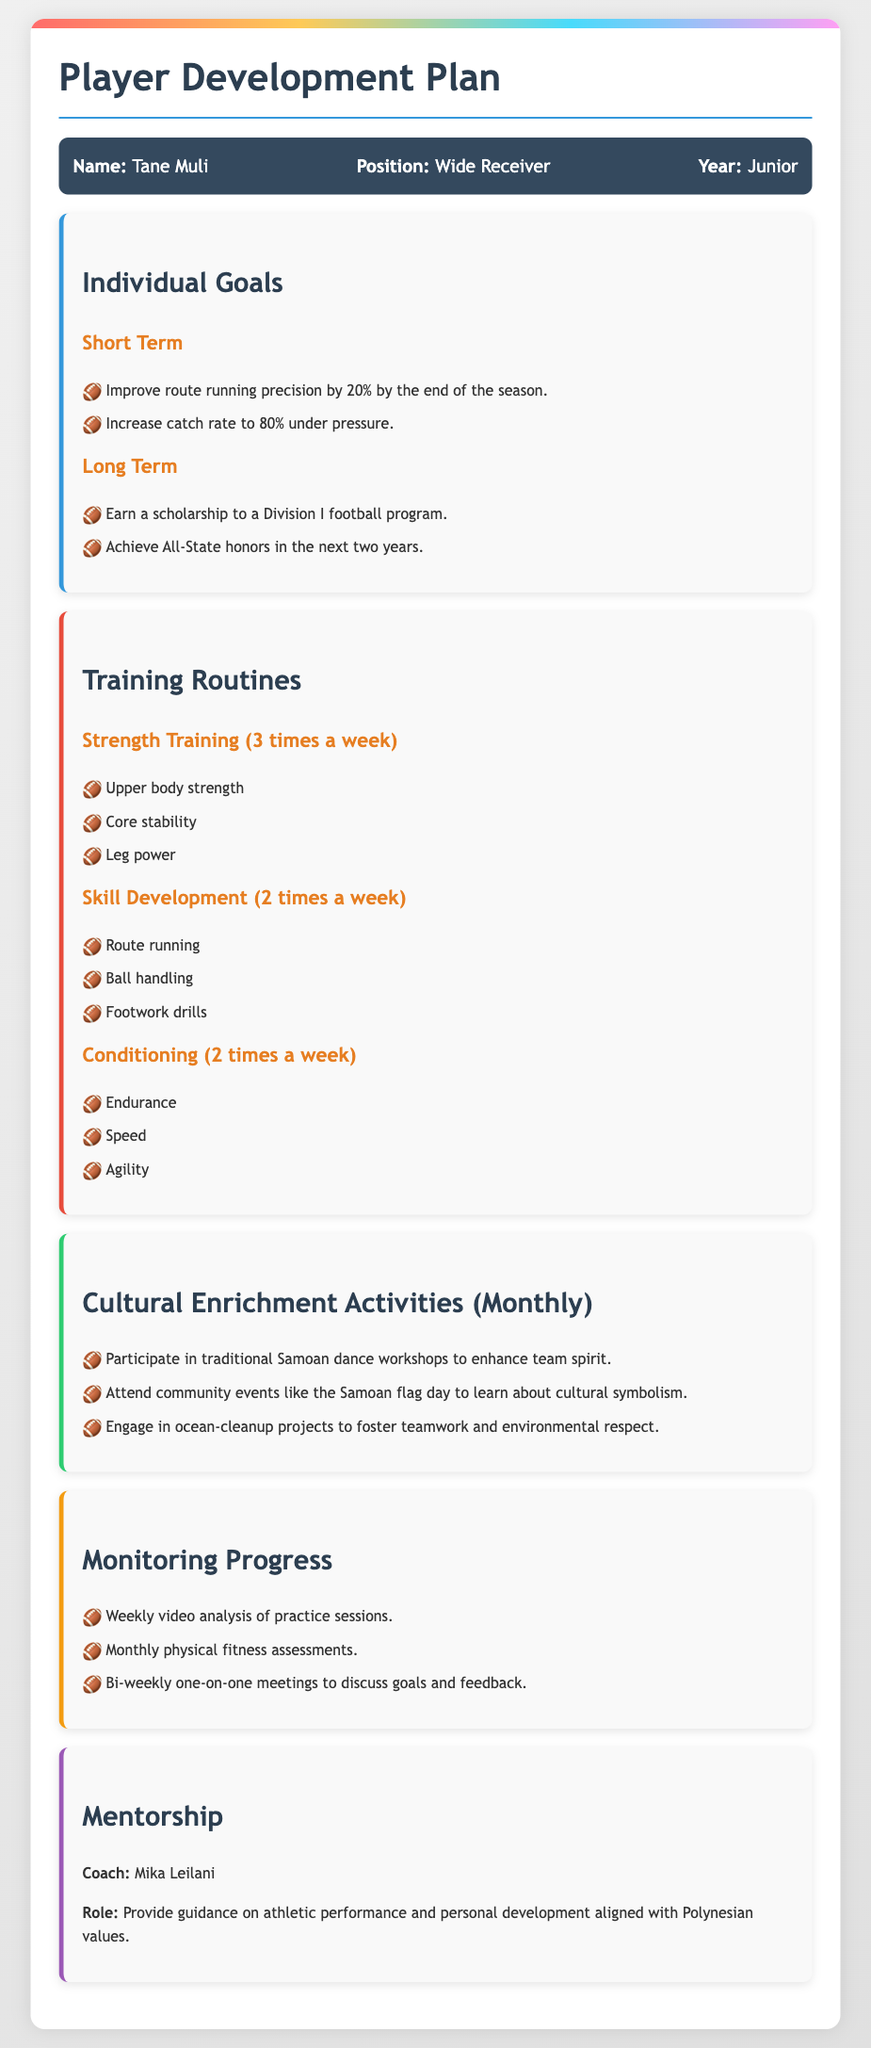What is the athlete's name? The name of the athlete is mentioned in the document, specifically in the athlete info section.
Answer: Tane Muli What position does Tane Muli play? The position of the athlete is specified in the document under the athlete info section.
Answer: Wide Receiver What is the short-term goal related to catch rate? This goal is listed under the individual goals for improving performance metrics in the document.
Answer: Increase catch rate to 80% under pressure How many times a week does Tane Muli engage in strength training? The training routine section specifies the frequency for each type of training.
Answer: 3 times a week What cultural activity focuses on teamwork and environmental respect? This is one of the activities listed under cultural enrichment activities.
Answer: Ocean-cleanup projects Who is Tane Muli's coach? The mentorship section of the document provides the name of the coach.
Answer: Mika Leilani What long-term goal involves earning recognition? The document states a goal related to honors Tane Muli aims to achieve over time.
Answer: Achieve All-State honors in the next two years How frequently are physical fitness assessments conducted? The monitoring section outlines how often various progress evaluations take place.
Answer: Monthly What is one of the key focuses in skill development training? This information is included under training routines in the document.
Answer: Route running 